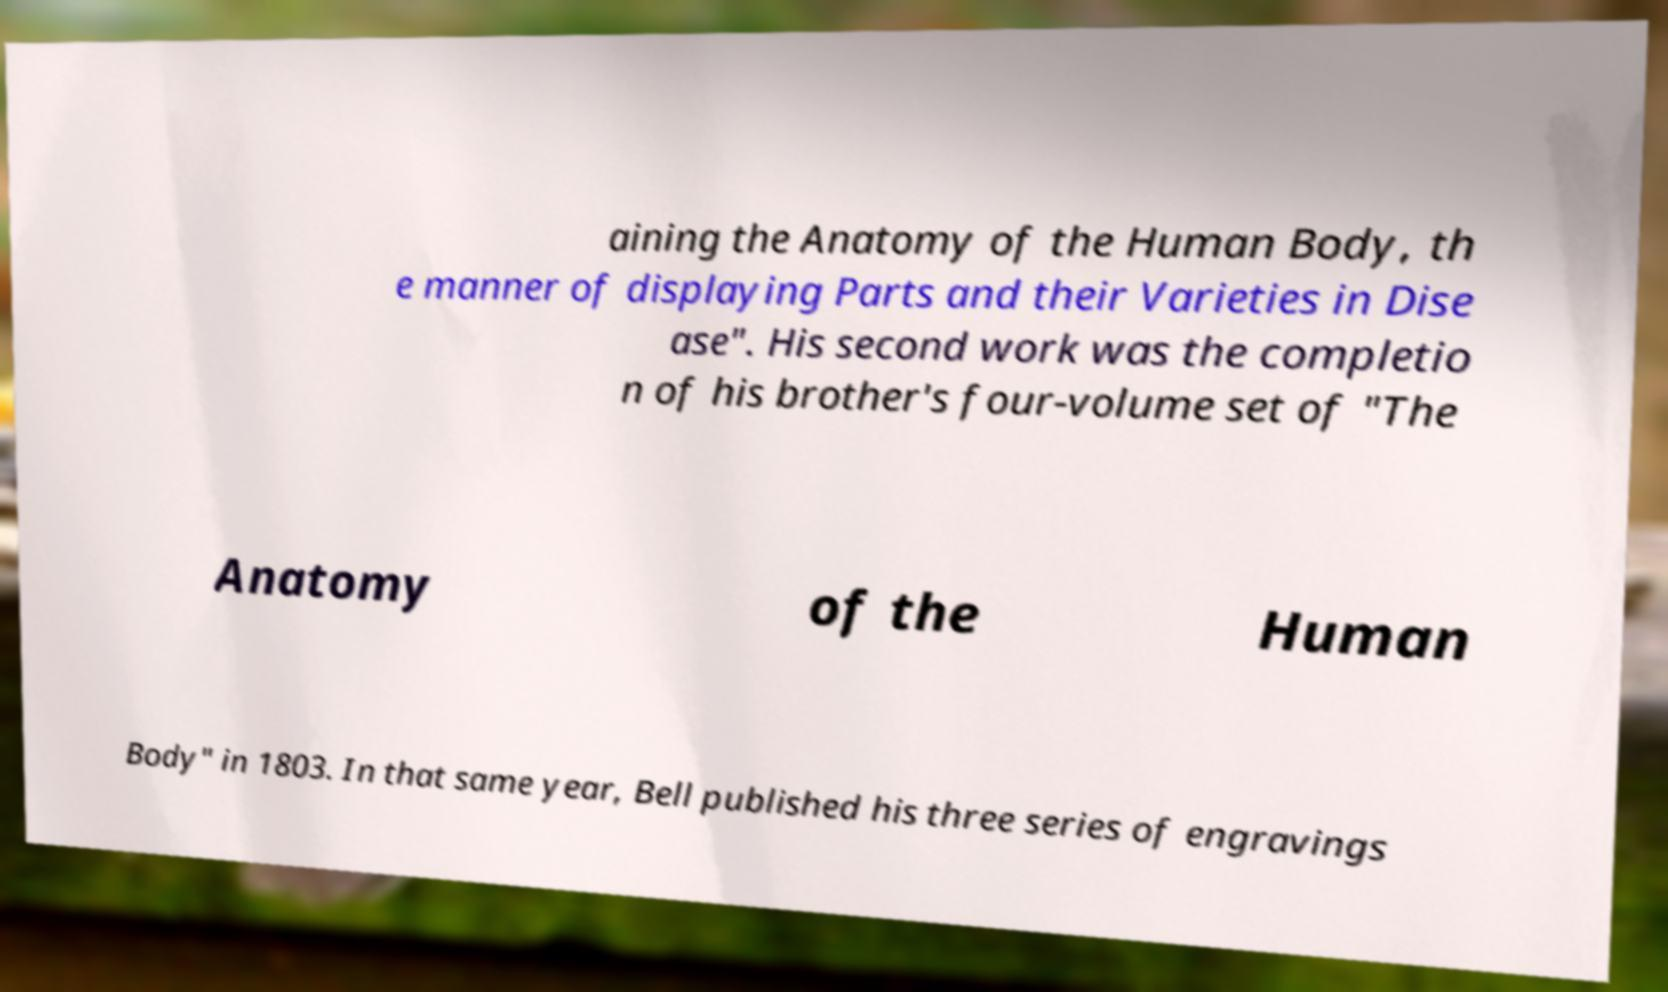Can you accurately transcribe the text from the provided image for me? aining the Anatomy of the Human Body, th e manner of displaying Parts and their Varieties in Dise ase". His second work was the completio n of his brother's four-volume set of "The Anatomy of the Human Body" in 1803. In that same year, Bell published his three series of engravings 